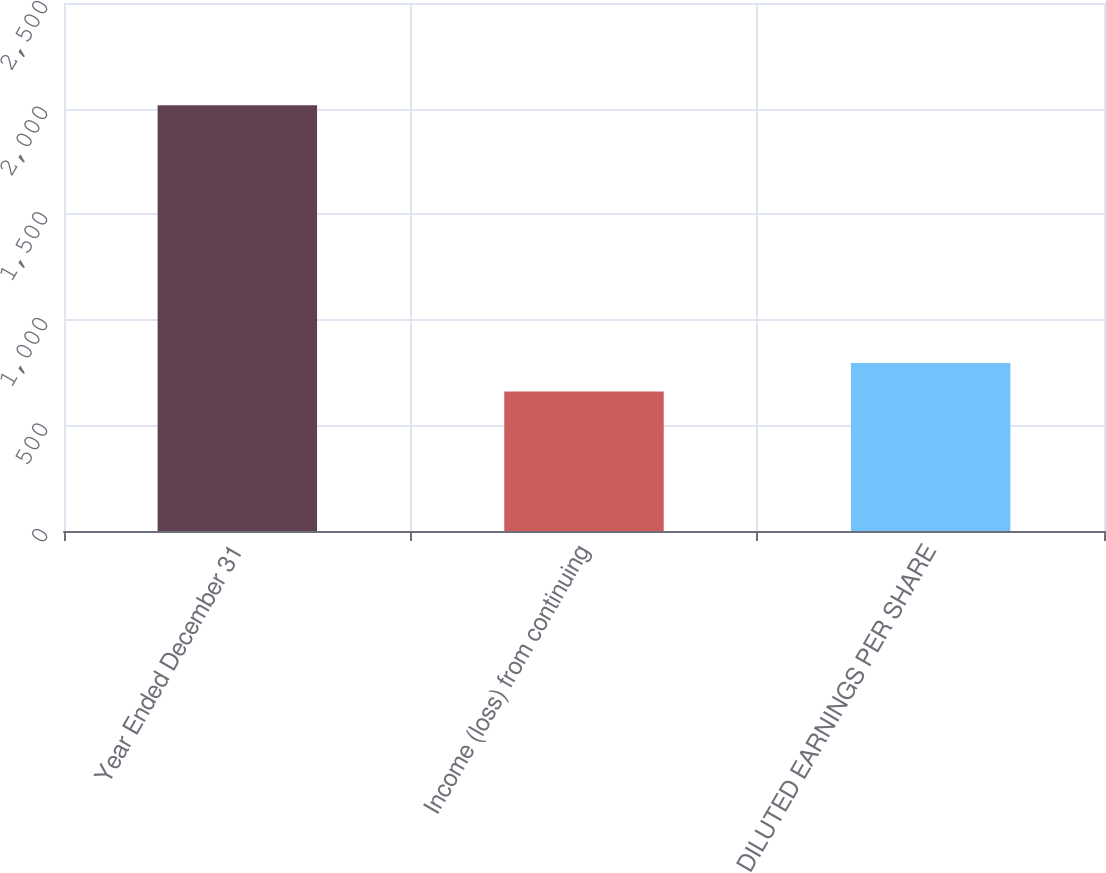Convert chart to OTSL. <chart><loc_0><loc_0><loc_500><loc_500><bar_chart><fcel>Year Ended December 31<fcel>Income (loss) from continuing<fcel>DILUTED EARNINGS PER SHARE<nl><fcel>2016<fcel>660<fcel>795.6<nl></chart> 